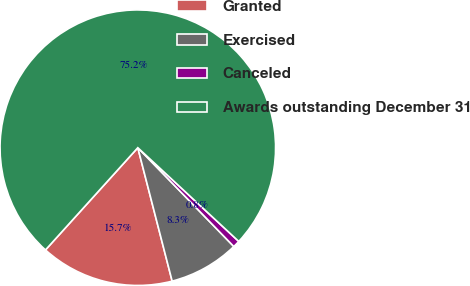Convert chart. <chart><loc_0><loc_0><loc_500><loc_500><pie_chart><fcel>Granted<fcel>Exercised<fcel>Canceled<fcel>Awards outstanding December 31<nl><fcel>15.7%<fcel>8.26%<fcel>0.82%<fcel>75.21%<nl></chart> 